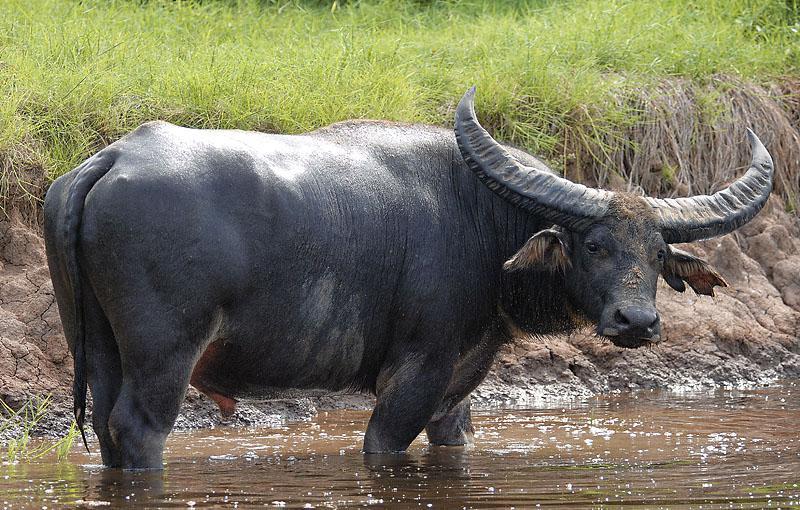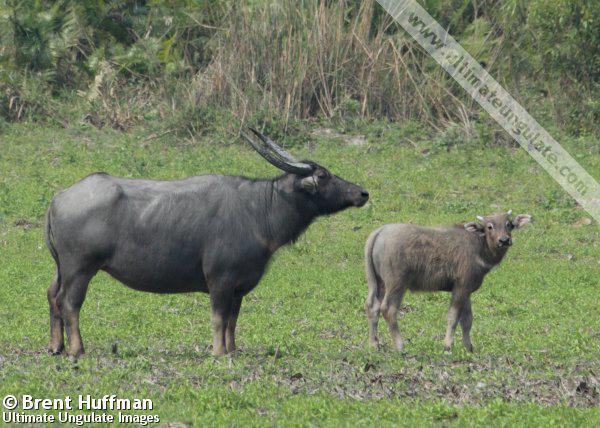The first image is the image on the left, the second image is the image on the right. Considering the images on both sides, is "There are no less than two Water Buffalo in one of the images." valid? Answer yes or no. Yes. The first image is the image on the left, the second image is the image on the right. Analyze the images presented: Is the assertion "In one image there is a lone water buffalo standing in water." valid? Answer yes or no. Yes. 